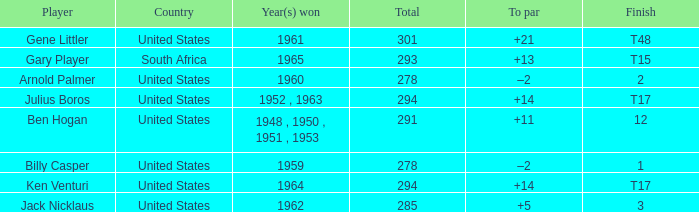What is Country, when Year(s) Won is "1962"? United States. 